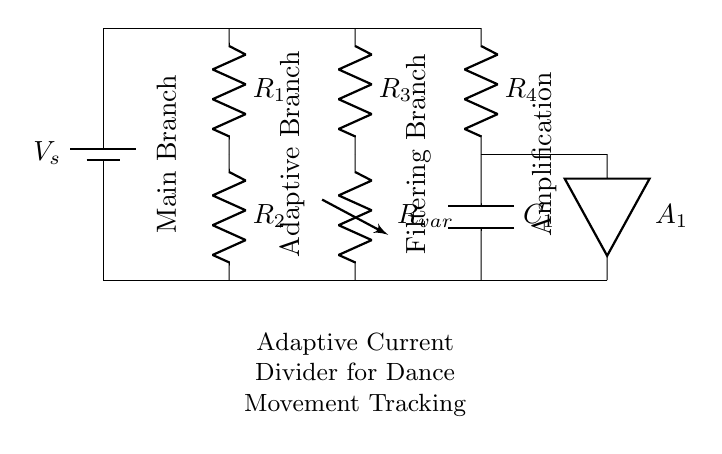What is the value of the source voltage? The circuit does not explicitly show a numerical value for the source voltage in the diagram. Therefore, it remains variable and is specified simply as Vs.
Answer: Vs What components are present in the main branch? The main branch consists of a battery and two resistors, R1 and R2, connected in series. This is evident as they are the first components displayed in the circuit's layout.
Answer: Battery, R1, R2 What is the role of the variable resistor \( R_{var} \)? The variable resistor \( R_{var} \) is located in the adaptive branch and is adjustable, allowing it to vary the current flowing through this branch as needed for tracking dance movements. Its presence indicates that this current divider circuit can adapt to changing conditions.
Answer: Current adjustment How many branches are in the circuit? The circuit diagram showcases four distinct branches: the main branch, adaptive branch, filtering branch, and amplification. Each branch serves a specific function within the overall design.
Answer: Four In which branch is the capacitor located? The capacitor \( C_1 \) is placed in the filtering branch, as can be seen from its direct connection that follows the resistor \( R_4 \) before completing the circuit back to the ground. This implies it plays a role in filtering signals from this branch.
Answer: Filtering branch What type of circuit is this? This is a current divider circuit specifically tailored to monitor and track dance movements. It utilizes various components to adapt and filter signals based on current division principles.
Answer: Current divider circuit 